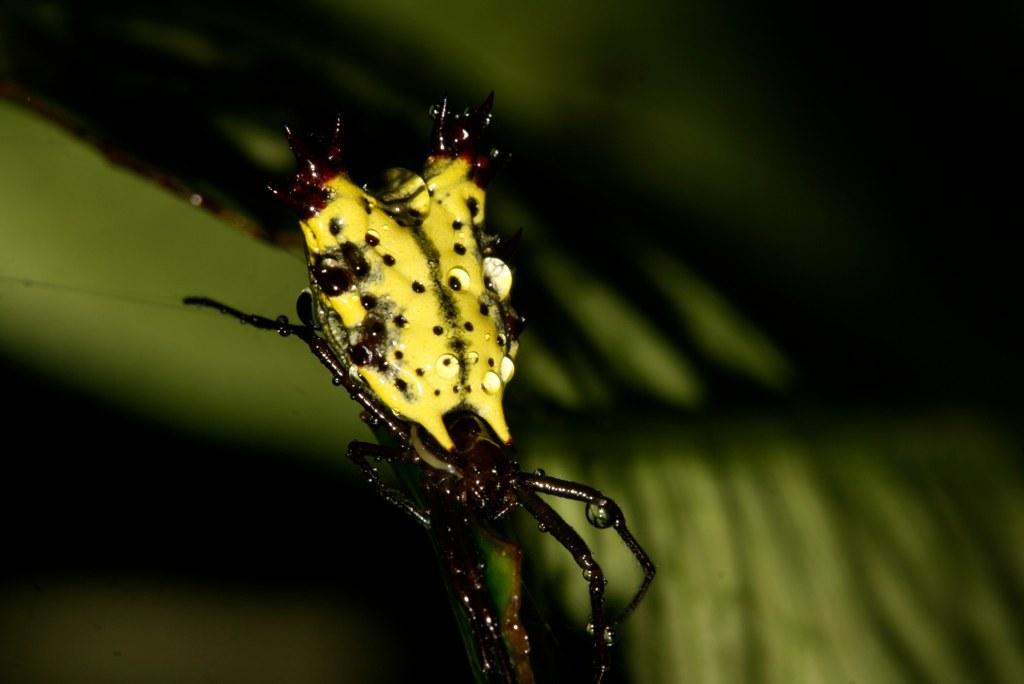What is the main subject in the foreground of the image? There is an insect in the foreground of the image. What can be observed about the background of the image? The background of the image is blurred. What type of stew is being prepared in the background of the image? There is no stew present in the image; the background is blurred and does not show any cooking activity. What kind of apparel is the insect wearing in the image? Insects do not wear apparel, so this question cannot be answered based on the image. 